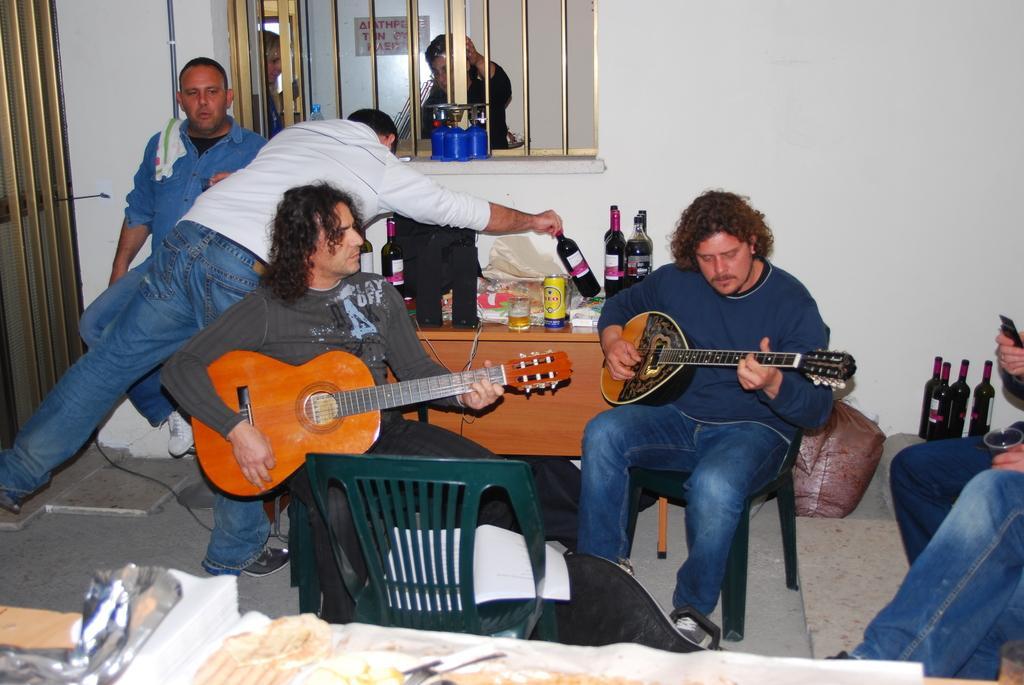Please provide a concise description of this image. In this picture we can see two persons are sitting on the chairs and they are playing guitars. On the background there is a wall and these are the bottles. And there is a table and this is the window. 